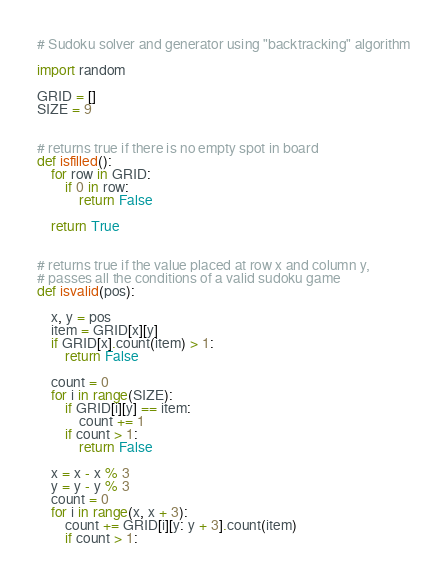Convert code to text. <code><loc_0><loc_0><loc_500><loc_500><_Python_>
# Sudoku solver and generator using "backtracking" algorithm

import random

GRID = []
SIZE = 9


# returns true if there is no empty spot in board
def isfilled():
    for row in GRID:
        if 0 in row:
            return False

    return True


# returns true if the value placed at row x and column y,
# passes all the conditions of a valid sudoku game
def isvalid(pos):

    x, y = pos
    item = GRID[x][y]
    if GRID[x].count(item) > 1:
        return False

    count = 0
    for i in range(SIZE):
        if GRID[i][y] == item:
            count += 1
        if count > 1:
            return False

    x = x - x % 3
    y = y - y % 3
    count = 0
    for i in range(x, x + 3):
        count += GRID[i][y: y + 3].count(item)
        if count > 1:</code> 